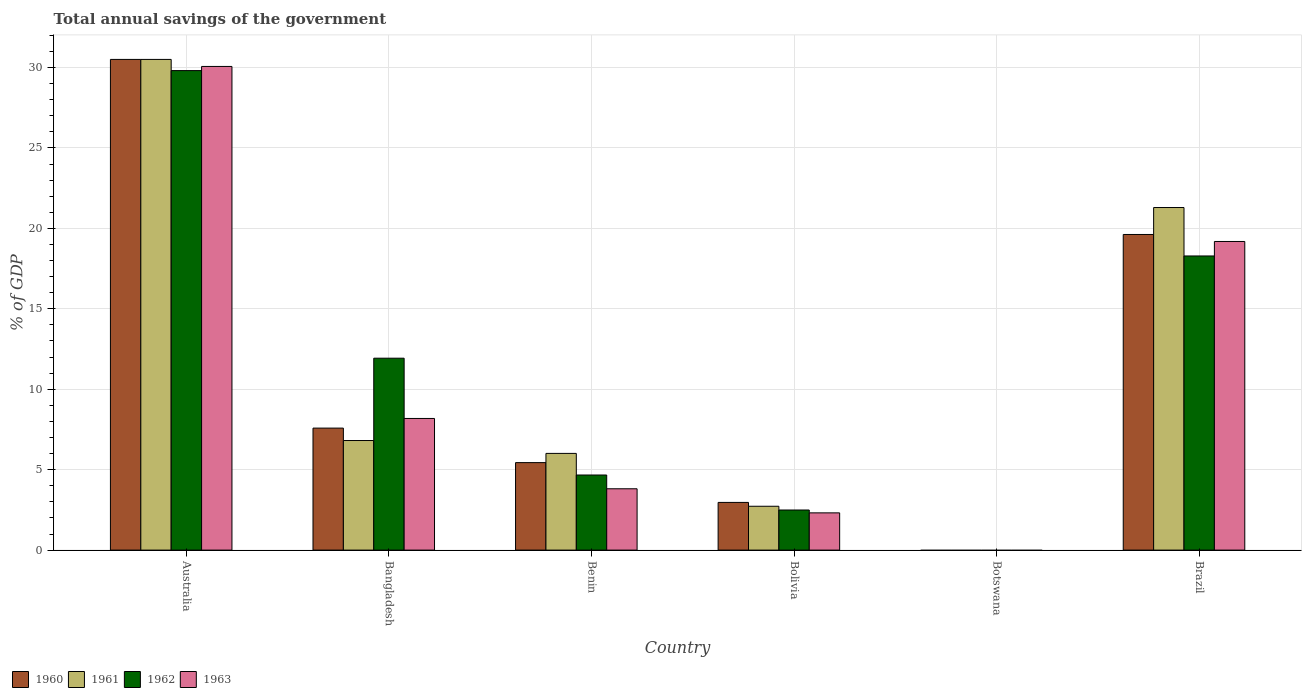Are the number of bars on each tick of the X-axis equal?
Your answer should be very brief. No. What is the label of the 5th group of bars from the left?
Your answer should be compact. Botswana. In how many cases, is the number of bars for a given country not equal to the number of legend labels?
Your response must be concise. 1. What is the total annual savings of the government in 1960 in Benin?
Your answer should be compact. 5.44. Across all countries, what is the maximum total annual savings of the government in 1960?
Offer a terse response. 30.5. What is the total total annual savings of the government in 1962 in the graph?
Ensure brevity in your answer.  67.18. What is the difference between the total annual savings of the government in 1961 in Australia and that in Brazil?
Your answer should be compact. 9.21. What is the difference between the total annual savings of the government in 1963 in Bolivia and the total annual savings of the government in 1962 in Australia?
Make the answer very short. -27.49. What is the average total annual savings of the government in 1963 per country?
Your answer should be compact. 10.59. What is the difference between the total annual savings of the government of/in 1960 and total annual savings of the government of/in 1963 in Benin?
Your response must be concise. 1.63. What is the ratio of the total annual savings of the government in 1960 in Bangladesh to that in Brazil?
Ensure brevity in your answer.  0.39. Is the difference between the total annual savings of the government in 1960 in Benin and Brazil greater than the difference between the total annual savings of the government in 1963 in Benin and Brazil?
Your answer should be compact. Yes. What is the difference between the highest and the second highest total annual savings of the government in 1961?
Your answer should be very brief. -9.21. What is the difference between the highest and the lowest total annual savings of the government in 1960?
Offer a terse response. 30.5. In how many countries, is the total annual savings of the government in 1962 greater than the average total annual savings of the government in 1962 taken over all countries?
Your answer should be very brief. 3. Is the sum of the total annual savings of the government in 1962 in Australia and Bolivia greater than the maximum total annual savings of the government in 1960 across all countries?
Your answer should be compact. Yes. Is it the case that in every country, the sum of the total annual savings of the government in 1960 and total annual savings of the government in 1961 is greater than the sum of total annual savings of the government in 1962 and total annual savings of the government in 1963?
Ensure brevity in your answer.  No. Is it the case that in every country, the sum of the total annual savings of the government in 1963 and total annual savings of the government in 1962 is greater than the total annual savings of the government in 1961?
Offer a terse response. No. How many bars are there?
Give a very brief answer. 20. Are all the bars in the graph horizontal?
Give a very brief answer. No. Are the values on the major ticks of Y-axis written in scientific E-notation?
Provide a succinct answer. No. Does the graph contain any zero values?
Offer a terse response. Yes. Does the graph contain grids?
Your response must be concise. Yes. Where does the legend appear in the graph?
Your response must be concise. Bottom left. How are the legend labels stacked?
Make the answer very short. Horizontal. What is the title of the graph?
Ensure brevity in your answer.  Total annual savings of the government. What is the label or title of the Y-axis?
Provide a short and direct response. % of GDP. What is the % of GDP of 1960 in Australia?
Provide a short and direct response. 30.5. What is the % of GDP in 1961 in Australia?
Offer a very short reply. 30.5. What is the % of GDP of 1962 in Australia?
Offer a terse response. 29.81. What is the % of GDP of 1963 in Australia?
Give a very brief answer. 30.07. What is the % of GDP of 1960 in Bangladesh?
Provide a succinct answer. 7.58. What is the % of GDP in 1961 in Bangladesh?
Give a very brief answer. 6.81. What is the % of GDP in 1962 in Bangladesh?
Ensure brevity in your answer.  11.93. What is the % of GDP of 1963 in Bangladesh?
Offer a terse response. 8.18. What is the % of GDP in 1960 in Benin?
Ensure brevity in your answer.  5.44. What is the % of GDP in 1961 in Benin?
Your answer should be compact. 6.01. What is the % of GDP in 1962 in Benin?
Offer a very short reply. 4.67. What is the % of GDP in 1963 in Benin?
Ensure brevity in your answer.  3.81. What is the % of GDP of 1960 in Bolivia?
Keep it short and to the point. 2.96. What is the % of GDP in 1961 in Bolivia?
Provide a short and direct response. 2.73. What is the % of GDP in 1962 in Bolivia?
Your answer should be very brief. 2.49. What is the % of GDP of 1963 in Bolivia?
Make the answer very short. 2.32. What is the % of GDP of 1960 in Botswana?
Ensure brevity in your answer.  0. What is the % of GDP of 1961 in Botswana?
Offer a very short reply. 0. What is the % of GDP in 1963 in Botswana?
Offer a very short reply. 0. What is the % of GDP in 1960 in Brazil?
Your answer should be compact. 19.62. What is the % of GDP in 1961 in Brazil?
Keep it short and to the point. 21.3. What is the % of GDP of 1962 in Brazil?
Give a very brief answer. 18.28. What is the % of GDP in 1963 in Brazil?
Offer a terse response. 19.19. Across all countries, what is the maximum % of GDP in 1960?
Provide a short and direct response. 30.5. Across all countries, what is the maximum % of GDP in 1961?
Make the answer very short. 30.5. Across all countries, what is the maximum % of GDP of 1962?
Ensure brevity in your answer.  29.81. Across all countries, what is the maximum % of GDP of 1963?
Your answer should be very brief. 30.07. Across all countries, what is the minimum % of GDP in 1960?
Give a very brief answer. 0. Across all countries, what is the minimum % of GDP in 1963?
Your answer should be compact. 0. What is the total % of GDP of 1960 in the graph?
Your answer should be very brief. 66.11. What is the total % of GDP of 1961 in the graph?
Ensure brevity in your answer.  67.35. What is the total % of GDP of 1962 in the graph?
Your response must be concise. 67.18. What is the total % of GDP of 1963 in the graph?
Your answer should be compact. 63.56. What is the difference between the % of GDP of 1960 in Australia and that in Bangladesh?
Give a very brief answer. 22.92. What is the difference between the % of GDP in 1961 in Australia and that in Bangladesh?
Offer a terse response. 23.69. What is the difference between the % of GDP in 1962 in Australia and that in Bangladesh?
Provide a short and direct response. 17.88. What is the difference between the % of GDP of 1963 in Australia and that in Bangladesh?
Keep it short and to the point. 21.88. What is the difference between the % of GDP in 1960 in Australia and that in Benin?
Make the answer very short. 25.06. What is the difference between the % of GDP of 1961 in Australia and that in Benin?
Make the answer very short. 24.49. What is the difference between the % of GDP in 1962 in Australia and that in Benin?
Keep it short and to the point. 25.14. What is the difference between the % of GDP of 1963 in Australia and that in Benin?
Make the answer very short. 26.25. What is the difference between the % of GDP of 1960 in Australia and that in Bolivia?
Ensure brevity in your answer.  27.54. What is the difference between the % of GDP in 1961 in Australia and that in Bolivia?
Ensure brevity in your answer.  27.78. What is the difference between the % of GDP of 1962 in Australia and that in Bolivia?
Offer a terse response. 27.31. What is the difference between the % of GDP in 1963 in Australia and that in Bolivia?
Keep it short and to the point. 27.75. What is the difference between the % of GDP in 1960 in Australia and that in Brazil?
Your answer should be very brief. 10.88. What is the difference between the % of GDP in 1961 in Australia and that in Brazil?
Make the answer very short. 9.21. What is the difference between the % of GDP in 1962 in Australia and that in Brazil?
Your response must be concise. 11.52. What is the difference between the % of GDP in 1963 in Australia and that in Brazil?
Ensure brevity in your answer.  10.88. What is the difference between the % of GDP of 1960 in Bangladesh and that in Benin?
Keep it short and to the point. 2.15. What is the difference between the % of GDP of 1961 in Bangladesh and that in Benin?
Give a very brief answer. 0.8. What is the difference between the % of GDP of 1962 in Bangladesh and that in Benin?
Give a very brief answer. 7.26. What is the difference between the % of GDP of 1963 in Bangladesh and that in Benin?
Offer a very short reply. 4.37. What is the difference between the % of GDP in 1960 in Bangladesh and that in Bolivia?
Offer a terse response. 4.62. What is the difference between the % of GDP of 1961 in Bangladesh and that in Bolivia?
Provide a short and direct response. 4.09. What is the difference between the % of GDP in 1962 in Bangladesh and that in Bolivia?
Your response must be concise. 9.44. What is the difference between the % of GDP of 1963 in Bangladesh and that in Bolivia?
Offer a very short reply. 5.87. What is the difference between the % of GDP of 1960 in Bangladesh and that in Brazil?
Provide a short and direct response. -12.04. What is the difference between the % of GDP of 1961 in Bangladesh and that in Brazil?
Your answer should be very brief. -14.48. What is the difference between the % of GDP of 1962 in Bangladesh and that in Brazil?
Provide a short and direct response. -6.36. What is the difference between the % of GDP in 1963 in Bangladesh and that in Brazil?
Ensure brevity in your answer.  -11. What is the difference between the % of GDP of 1960 in Benin and that in Bolivia?
Make the answer very short. 2.47. What is the difference between the % of GDP of 1961 in Benin and that in Bolivia?
Make the answer very short. 3.29. What is the difference between the % of GDP of 1962 in Benin and that in Bolivia?
Your answer should be very brief. 2.17. What is the difference between the % of GDP of 1963 in Benin and that in Bolivia?
Make the answer very short. 1.5. What is the difference between the % of GDP in 1960 in Benin and that in Brazil?
Offer a terse response. -14.18. What is the difference between the % of GDP in 1961 in Benin and that in Brazil?
Offer a very short reply. -15.28. What is the difference between the % of GDP in 1962 in Benin and that in Brazil?
Offer a very short reply. -13.62. What is the difference between the % of GDP in 1963 in Benin and that in Brazil?
Your answer should be compact. -15.37. What is the difference between the % of GDP in 1960 in Bolivia and that in Brazil?
Give a very brief answer. -16.66. What is the difference between the % of GDP in 1961 in Bolivia and that in Brazil?
Your response must be concise. -18.57. What is the difference between the % of GDP of 1962 in Bolivia and that in Brazil?
Keep it short and to the point. -15.79. What is the difference between the % of GDP in 1963 in Bolivia and that in Brazil?
Your answer should be compact. -16.87. What is the difference between the % of GDP of 1960 in Australia and the % of GDP of 1961 in Bangladesh?
Offer a terse response. 23.69. What is the difference between the % of GDP in 1960 in Australia and the % of GDP in 1962 in Bangladesh?
Keep it short and to the point. 18.57. What is the difference between the % of GDP of 1960 in Australia and the % of GDP of 1963 in Bangladesh?
Offer a terse response. 22.32. What is the difference between the % of GDP of 1961 in Australia and the % of GDP of 1962 in Bangladesh?
Your response must be concise. 18.57. What is the difference between the % of GDP of 1961 in Australia and the % of GDP of 1963 in Bangladesh?
Provide a succinct answer. 22.32. What is the difference between the % of GDP of 1962 in Australia and the % of GDP of 1963 in Bangladesh?
Offer a very short reply. 21.62. What is the difference between the % of GDP in 1960 in Australia and the % of GDP in 1961 in Benin?
Keep it short and to the point. 24.49. What is the difference between the % of GDP of 1960 in Australia and the % of GDP of 1962 in Benin?
Offer a terse response. 25.83. What is the difference between the % of GDP of 1960 in Australia and the % of GDP of 1963 in Benin?
Give a very brief answer. 26.69. What is the difference between the % of GDP in 1961 in Australia and the % of GDP in 1962 in Benin?
Provide a short and direct response. 25.84. What is the difference between the % of GDP in 1961 in Australia and the % of GDP in 1963 in Benin?
Offer a very short reply. 26.69. What is the difference between the % of GDP of 1962 in Australia and the % of GDP of 1963 in Benin?
Make the answer very short. 26. What is the difference between the % of GDP in 1960 in Australia and the % of GDP in 1961 in Bolivia?
Provide a short and direct response. 27.78. What is the difference between the % of GDP in 1960 in Australia and the % of GDP in 1962 in Bolivia?
Give a very brief answer. 28.01. What is the difference between the % of GDP in 1960 in Australia and the % of GDP in 1963 in Bolivia?
Provide a short and direct response. 28.19. What is the difference between the % of GDP of 1961 in Australia and the % of GDP of 1962 in Bolivia?
Ensure brevity in your answer.  28.01. What is the difference between the % of GDP of 1961 in Australia and the % of GDP of 1963 in Bolivia?
Your response must be concise. 28.19. What is the difference between the % of GDP of 1962 in Australia and the % of GDP of 1963 in Bolivia?
Provide a succinct answer. 27.49. What is the difference between the % of GDP of 1960 in Australia and the % of GDP of 1961 in Brazil?
Your answer should be compact. 9.21. What is the difference between the % of GDP of 1960 in Australia and the % of GDP of 1962 in Brazil?
Offer a very short reply. 12.22. What is the difference between the % of GDP in 1960 in Australia and the % of GDP in 1963 in Brazil?
Your answer should be very brief. 11.32. What is the difference between the % of GDP of 1961 in Australia and the % of GDP of 1962 in Brazil?
Make the answer very short. 12.22. What is the difference between the % of GDP of 1961 in Australia and the % of GDP of 1963 in Brazil?
Your response must be concise. 11.32. What is the difference between the % of GDP in 1962 in Australia and the % of GDP in 1963 in Brazil?
Give a very brief answer. 10.62. What is the difference between the % of GDP in 1960 in Bangladesh and the % of GDP in 1961 in Benin?
Offer a terse response. 1.57. What is the difference between the % of GDP of 1960 in Bangladesh and the % of GDP of 1962 in Benin?
Your answer should be very brief. 2.92. What is the difference between the % of GDP of 1960 in Bangladesh and the % of GDP of 1963 in Benin?
Give a very brief answer. 3.77. What is the difference between the % of GDP in 1961 in Bangladesh and the % of GDP in 1962 in Benin?
Provide a succinct answer. 2.14. What is the difference between the % of GDP of 1961 in Bangladesh and the % of GDP of 1963 in Benin?
Offer a very short reply. 3. What is the difference between the % of GDP of 1962 in Bangladesh and the % of GDP of 1963 in Benin?
Your response must be concise. 8.12. What is the difference between the % of GDP in 1960 in Bangladesh and the % of GDP in 1961 in Bolivia?
Give a very brief answer. 4.86. What is the difference between the % of GDP of 1960 in Bangladesh and the % of GDP of 1962 in Bolivia?
Give a very brief answer. 5.09. What is the difference between the % of GDP in 1960 in Bangladesh and the % of GDP in 1963 in Bolivia?
Keep it short and to the point. 5.27. What is the difference between the % of GDP of 1961 in Bangladesh and the % of GDP of 1962 in Bolivia?
Your answer should be compact. 4.32. What is the difference between the % of GDP in 1961 in Bangladesh and the % of GDP in 1963 in Bolivia?
Ensure brevity in your answer.  4.5. What is the difference between the % of GDP in 1962 in Bangladesh and the % of GDP in 1963 in Bolivia?
Provide a short and direct response. 9.61. What is the difference between the % of GDP in 1960 in Bangladesh and the % of GDP in 1961 in Brazil?
Provide a succinct answer. -13.71. What is the difference between the % of GDP in 1960 in Bangladesh and the % of GDP in 1962 in Brazil?
Make the answer very short. -10.7. What is the difference between the % of GDP of 1960 in Bangladesh and the % of GDP of 1963 in Brazil?
Give a very brief answer. -11.6. What is the difference between the % of GDP of 1961 in Bangladesh and the % of GDP of 1962 in Brazil?
Your answer should be very brief. -11.47. What is the difference between the % of GDP in 1961 in Bangladesh and the % of GDP in 1963 in Brazil?
Your answer should be compact. -12.37. What is the difference between the % of GDP of 1962 in Bangladesh and the % of GDP of 1963 in Brazil?
Make the answer very short. -7.26. What is the difference between the % of GDP of 1960 in Benin and the % of GDP of 1961 in Bolivia?
Offer a very short reply. 2.71. What is the difference between the % of GDP in 1960 in Benin and the % of GDP in 1962 in Bolivia?
Your response must be concise. 2.95. What is the difference between the % of GDP in 1960 in Benin and the % of GDP in 1963 in Bolivia?
Ensure brevity in your answer.  3.12. What is the difference between the % of GDP in 1961 in Benin and the % of GDP in 1962 in Bolivia?
Make the answer very short. 3.52. What is the difference between the % of GDP in 1961 in Benin and the % of GDP in 1963 in Bolivia?
Your answer should be compact. 3.7. What is the difference between the % of GDP in 1962 in Benin and the % of GDP in 1963 in Bolivia?
Provide a short and direct response. 2.35. What is the difference between the % of GDP of 1960 in Benin and the % of GDP of 1961 in Brazil?
Offer a very short reply. -15.86. What is the difference between the % of GDP of 1960 in Benin and the % of GDP of 1962 in Brazil?
Your response must be concise. -12.85. What is the difference between the % of GDP in 1960 in Benin and the % of GDP in 1963 in Brazil?
Ensure brevity in your answer.  -13.75. What is the difference between the % of GDP of 1961 in Benin and the % of GDP of 1962 in Brazil?
Offer a terse response. -12.27. What is the difference between the % of GDP of 1961 in Benin and the % of GDP of 1963 in Brazil?
Provide a succinct answer. -13.17. What is the difference between the % of GDP in 1962 in Benin and the % of GDP in 1963 in Brazil?
Give a very brief answer. -14.52. What is the difference between the % of GDP of 1960 in Bolivia and the % of GDP of 1961 in Brazil?
Give a very brief answer. -18.33. What is the difference between the % of GDP of 1960 in Bolivia and the % of GDP of 1962 in Brazil?
Your answer should be very brief. -15.32. What is the difference between the % of GDP in 1960 in Bolivia and the % of GDP in 1963 in Brazil?
Offer a terse response. -16.22. What is the difference between the % of GDP of 1961 in Bolivia and the % of GDP of 1962 in Brazil?
Provide a succinct answer. -15.56. What is the difference between the % of GDP of 1961 in Bolivia and the % of GDP of 1963 in Brazil?
Offer a terse response. -16.46. What is the difference between the % of GDP in 1962 in Bolivia and the % of GDP in 1963 in Brazil?
Make the answer very short. -16.69. What is the average % of GDP in 1960 per country?
Ensure brevity in your answer.  11.02. What is the average % of GDP in 1961 per country?
Your answer should be compact. 11.22. What is the average % of GDP in 1962 per country?
Provide a succinct answer. 11.2. What is the average % of GDP in 1963 per country?
Give a very brief answer. 10.59. What is the difference between the % of GDP in 1960 and % of GDP in 1961 in Australia?
Your answer should be very brief. -0. What is the difference between the % of GDP in 1960 and % of GDP in 1962 in Australia?
Offer a very short reply. 0.7. What is the difference between the % of GDP in 1960 and % of GDP in 1963 in Australia?
Your response must be concise. 0.44. What is the difference between the % of GDP of 1961 and % of GDP of 1962 in Australia?
Keep it short and to the point. 0.7. What is the difference between the % of GDP of 1961 and % of GDP of 1963 in Australia?
Ensure brevity in your answer.  0.44. What is the difference between the % of GDP in 1962 and % of GDP in 1963 in Australia?
Your response must be concise. -0.26. What is the difference between the % of GDP in 1960 and % of GDP in 1961 in Bangladesh?
Your answer should be compact. 0.77. What is the difference between the % of GDP in 1960 and % of GDP in 1962 in Bangladesh?
Make the answer very short. -4.35. What is the difference between the % of GDP of 1960 and % of GDP of 1963 in Bangladesh?
Offer a very short reply. -0.6. What is the difference between the % of GDP in 1961 and % of GDP in 1962 in Bangladesh?
Offer a terse response. -5.12. What is the difference between the % of GDP in 1961 and % of GDP in 1963 in Bangladesh?
Provide a short and direct response. -1.37. What is the difference between the % of GDP in 1962 and % of GDP in 1963 in Bangladesh?
Keep it short and to the point. 3.75. What is the difference between the % of GDP of 1960 and % of GDP of 1961 in Benin?
Give a very brief answer. -0.57. What is the difference between the % of GDP in 1960 and % of GDP in 1962 in Benin?
Your response must be concise. 0.77. What is the difference between the % of GDP in 1960 and % of GDP in 1963 in Benin?
Make the answer very short. 1.63. What is the difference between the % of GDP of 1961 and % of GDP of 1962 in Benin?
Your answer should be compact. 1.34. What is the difference between the % of GDP in 1961 and % of GDP in 1963 in Benin?
Ensure brevity in your answer.  2.2. What is the difference between the % of GDP of 1962 and % of GDP of 1963 in Benin?
Your response must be concise. 0.86. What is the difference between the % of GDP in 1960 and % of GDP in 1961 in Bolivia?
Provide a short and direct response. 0.24. What is the difference between the % of GDP in 1960 and % of GDP in 1962 in Bolivia?
Your answer should be compact. 0.47. What is the difference between the % of GDP in 1960 and % of GDP in 1963 in Bolivia?
Offer a terse response. 0.65. What is the difference between the % of GDP of 1961 and % of GDP of 1962 in Bolivia?
Offer a terse response. 0.23. What is the difference between the % of GDP of 1961 and % of GDP of 1963 in Bolivia?
Provide a succinct answer. 0.41. What is the difference between the % of GDP in 1962 and % of GDP in 1963 in Bolivia?
Ensure brevity in your answer.  0.18. What is the difference between the % of GDP of 1960 and % of GDP of 1961 in Brazil?
Provide a short and direct response. -1.68. What is the difference between the % of GDP of 1960 and % of GDP of 1962 in Brazil?
Provide a short and direct response. 1.34. What is the difference between the % of GDP in 1960 and % of GDP in 1963 in Brazil?
Your answer should be very brief. 0.43. What is the difference between the % of GDP in 1961 and % of GDP in 1962 in Brazil?
Offer a very short reply. 3.01. What is the difference between the % of GDP of 1961 and % of GDP of 1963 in Brazil?
Your answer should be very brief. 2.11. What is the difference between the % of GDP of 1962 and % of GDP of 1963 in Brazil?
Your answer should be compact. -0.9. What is the ratio of the % of GDP in 1960 in Australia to that in Bangladesh?
Provide a succinct answer. 4.02. What is the ratio of the % of GDP in 1961 in Australia to that in Bangladesh?
Ensure brevity in your answer.  4.48. What is the ratio of the % of GDP in 1962 in Australia to that in Bangladesh?
Make the answer very short. 2.5. What is the ratio of the % of GDP of 1963 in Australia to that in Bangladesh?
Your answer should be very brief. 3.67. What is the ratio of the % of GDP of 1960 in Australia to that in Benin?
Your answer should be compact. 5.61. What is the ratio of the % of GDP in 1961 in Australia to that in Benin?
Your answer should be very brief. 5.07. What is the ratio of the % of GDP of 1962 in Australia to that in Benin?
Provide a succinct answer. 6.39. What is the ratio of the % of GDP of 1963 in Australia to that in Benin?
Give a very brief answer. 7.89. What is the ratio of the % of GDP in 1960 in Australia to that in Bolivia?
Offer a very short reply. 10.29. What is the ratio of the % of GDP of 1961 in Australia to that in Bolivia?
Your answer should be compact. 11.19. What is the ratio of the % of GDP in 1962 in Australia to that in Bolivia?
Your response must be concise. 11.96. What is the ratio of the % of GDP in 1963 in Australia to that in Bolivia?
Make the answer very short. 12.99. What is the ratio of the % of GDP of 1960 in Australia to that in Brazil?
Provide a short and direct response. 1.55. What is the ratio of the % of GDP of 1961 in Australia to that in Brazil?
Your answer should be compact. 1.43. What is the ratio of the % of GDP in 1962 in Australia to that in Brazil?
Ensure brevity in your answer.  1.63. What is the ratio of the % of GDP in 1963 in Australia to that in Brazil?
Give a very brief answer. 1.57. What is the ratio of the % of GDP of 1960 in Bangladesh to that in Benin?
Make the answer very short. 1.39. What is the ratio of the % of GDP in 1961 in Bangladesh to that in Benin?
Give a very brief answer. 1.13. What is the ratio of the % of GDP of 1962 in Bangladesh to that in Benin?
Offer a very short reply. 2.56. What is the ratio of the % of GDP in 1963 in Bangladesh to that in Benin?
Provide a short and direct response. 2.15. What is the ratio of the % of GDP of 1960 in Bangladesh to that in Bolivia?
Provide a succinct answer. 2.56. What is the ratio of the % of GDP in 1961 in Bangladesh to that in Bolivia?
Your answer should be very brief. 2.5. What is the ratio of the % of GDP of 1962 in Bangladesh to that in Bolivia?
Make the answer very short. 4.79. What is the ratio of the % of GDP in 1963 in Bangladesh to that in Bolivia?
Your answer should be very brief. 3.53. What is the ratio of the % of GDP in 1960 in Bangladesh to that in Brazil?
Give a very brief answer. 0.39. What is the ratio of the % of GDP of 1961 in Bangladesh to that in Brazil?
Provide a short and direct response. 0.32. What is the ratio of the % of GDP in 1962 in Bangladesh to that in Brazil?
Ensure brevity in your answer.  0.65. What is the ratio of the % of GDP in 1963 in Bangladesh to that in Brazil?
Make the answer very short. 0.43. What is the ratio of the % of GDP in 1960 in Benin to that in Bolivia?
Your answer should be compact. 1.83. What is the ratio of the % of GDP in 1961 in Benin to that in Bolivia?
Keep it short and to the point. 2.21. What is the ratio of the % of GDP in 1962 in Benin to that in Bolivia?
Your answer should be very brief. 1.87. What is the ratio of the % of GDP in 1963 in Benin to that in Bolivia?
Make the answer very short. 1.65. What is the ratio of the % of GDP of 1960 in Benin to that in Brazil?
Your answer should be very brief. 0.28. What is the ratio of the % of GDP of 1961 in Benin to that in Brazil?
Provide a succinct answer. 0.28. What is the ratio of the % of GDP of 1962 in Benin to that in Brazil?
Your response must be concise. 0.26. What is the ratio of the % of GDP of 1963 in Benin to that in Brazil?
Give a very brief answer. 0.2. What is the ratio of the % of GDP in 1960 in Bolivia to that in Brazil?
Offer a terse response. 0.15. What is the ratio of the % of GDP of 1961 in Bolivia to that in Brazil?
Make the answer very short. 0.13. What is the ratio of the % of GDP in 1962 in Bolivia to that in Brazil?
Keep it short and to the point. 0.14. What is the ratio of the % of GDP in 1963 in Bolivia to that in Brazil?
Your response must be concise. 0.12. What is the difference between the highest and the second highest % of GDP of 1960?
Your answer should be compact. 10.88. What is the difference between the highest and the second highest % of GDP in 1961?
Make the answer very short. 9.21. What is the difference between the highest and the second highest % of GDP in 1962?
Ensure brevity in your answer.  11.52. What is the difference between the highest and the second highest % of GDP in 1963?
Offer a terse response. 10.88. What is the difference between the highest and the lowest % of GDP in 1960?
Make the answer very short. 30.5. What is the difference between the highest and the lowest % of GDP of 1961?
Offer a very short reply. 30.5. What is the difference between the highest and the lowest % of GDP of 1962?
Ensure brevity in your answer.  29.81. What is the difference between the highest and the lowest % of GDP in 1963?
Ensure brevity in your answer.  30.07. 